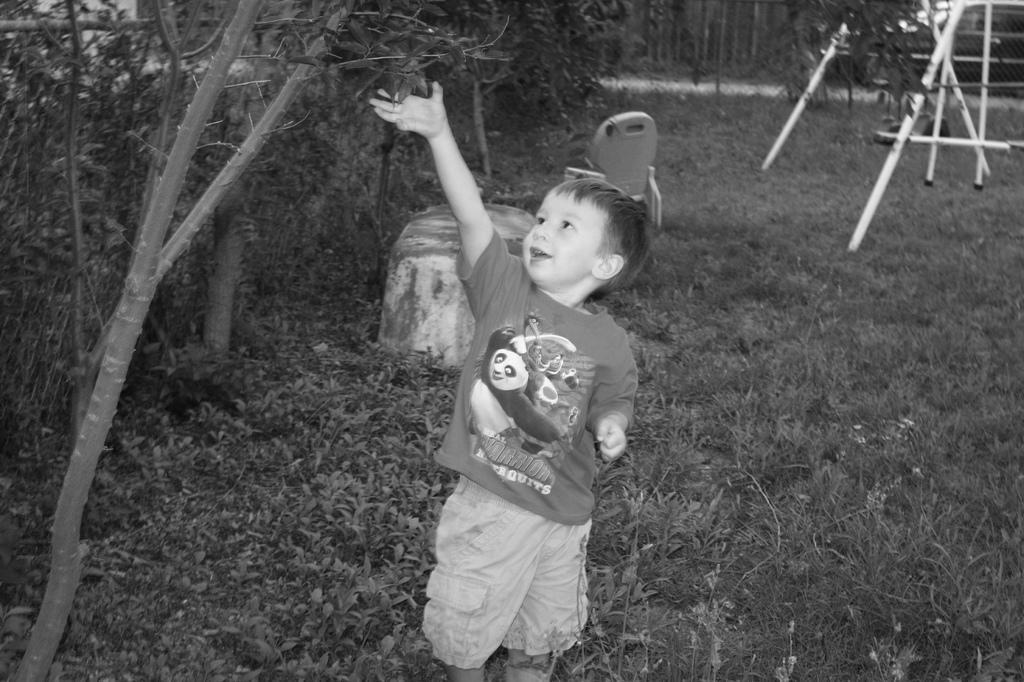Can you describe this image briefly? There is a kid standing on a greenery ground and touching leaves above him and there is a fence beside him and there are some other objects behind him. 